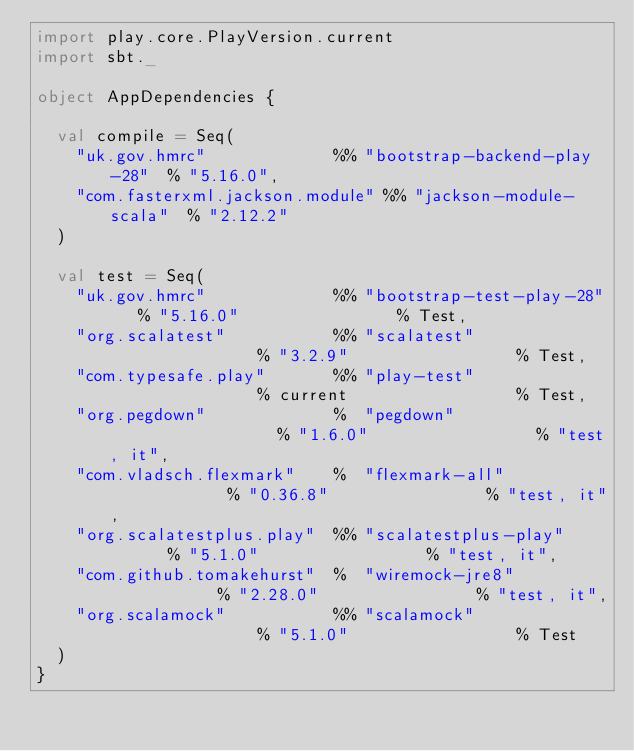<code> <loc_0><loc_0><loc_500><loc_500><_Scala_>import play.core.PlayVersion.current
import sbt._

object AppDependencies {

  val compile = Seq(
    "uk.gov.hmrc"             %% "bootstrap-backend-play-28"  % "5.16.0",
    "com.fasterxml.jackson.module" %% "jackson-module-scala"  % "2.12.2"
  )

  val test = Seq(
    "uk.gov.hmrc"             %% "bootstrap-test-play-28"   % "5.16.0"                % Test,
    "org.scalatest"           %% "scalatest"                % "3.2.9"                 % Test,
    "com.typesafe.play"       %% "play-test"                % current                 % Test,
    "org.pegdown"             %  "pegdown"                  % "1.6.0"                 % "test, it",
    "com.vladsch.flexmark"    %  "flexmark-all"             % "0.36.8"                % "test, it",
    "org.scalatestplus.play"  %% "scalatestplus-play"       % "5.1.0"                 % "test, it",
    "com.github.tomakehurst"  %  "wiremock-jre8"            % "2.28.0"                % "test, it",
    "org.scalamock"           %% "scalamock"                % "5.1.0"                 % Test
  )
}
</code> 